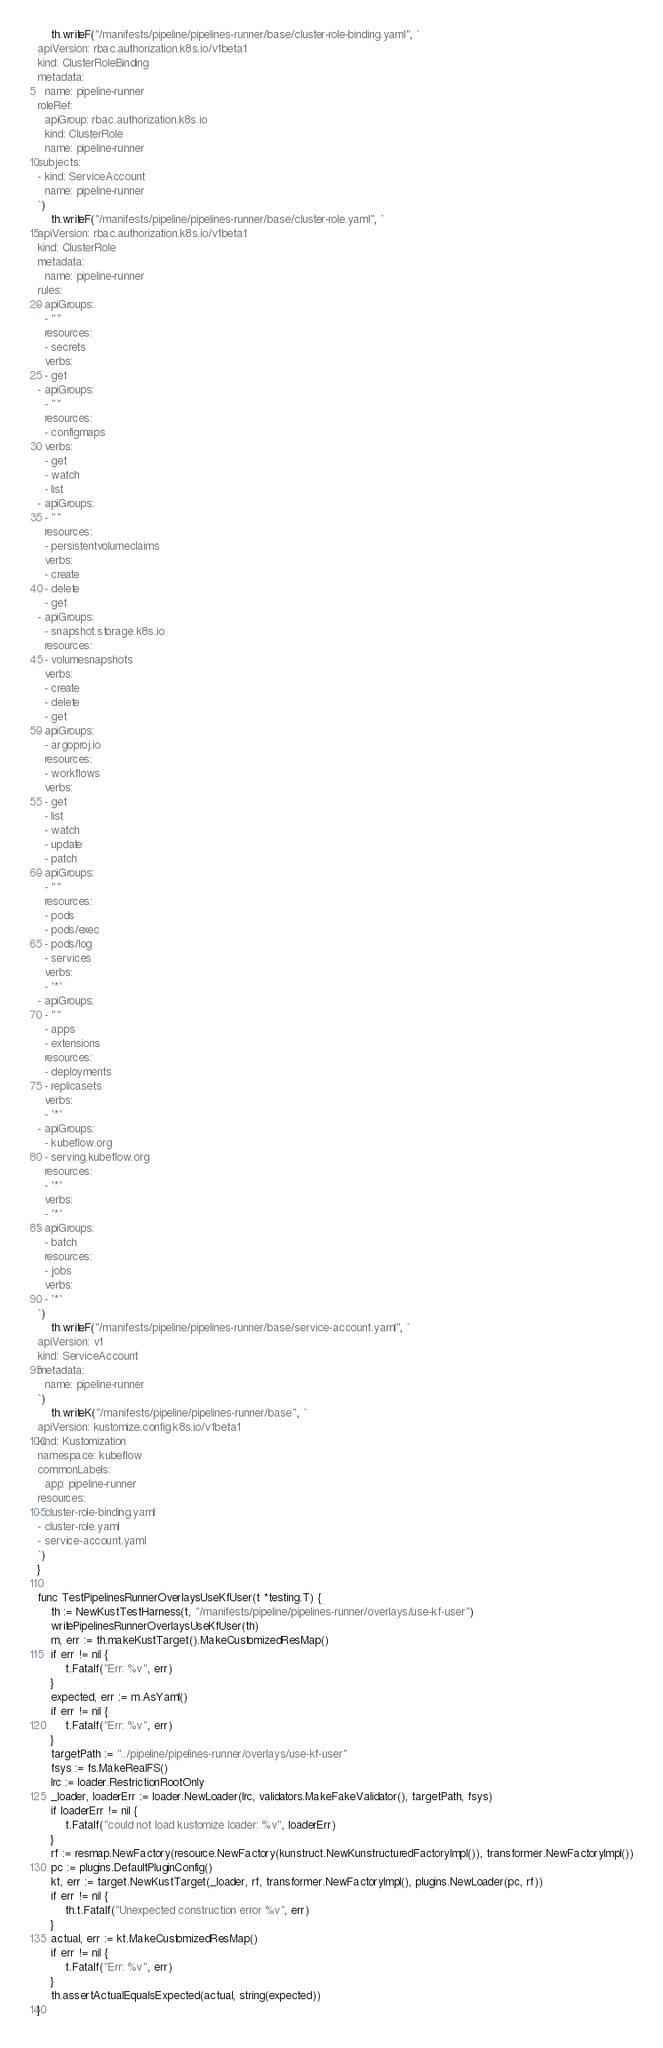<code> <loc_0><loc_0><loc_500><loc_500><_Go_>	th.writeF("/manifests/pipeline/pipelines-runner/base/cluster-role-binding.yaml", `
apiVersion: rbac.authorization.k8s.io/v1beta1
kind: ClusterRoleBinding
metadata:
  name: pipeline-runner
roleRef:
  apiGroup: rbac.authorization.k8s.io
  kind: ClusterRole
  name: pipeline-runner
subjects:
- kind: ServiceAccount
  name: pipeline-runner
`)
	th.writeF("/manifests/pipeline/pipelines-runner/base/cluster-role.yaml", `
apiVersion: rbac.authorization.k8s.io/v1beta1
kind: ClusterRole
metadata:
  name: pipeline-runner
rules:
- apiGroups:
  - ""
  resources:
  - secrets
  verbs:
  - get
- apiGroups:
  - ""
  resources:
  - configmaps
  verbs:
  - get
  - watch
  - list
- apiGroups:
  - ""
  resources:
  - persistentvolumeclaims
  verbs:
  - create
  - delete
  - get
- apiGroups:
  - snapshot.storage.k8s.io
  resources:
  - volumesnapshots
  verbs:
  - create
  - delete
  - get
- apiGroups:
  - argoproj.io
  resources:
  - workflows
  verbs:
  - get
  - list
  - watch
  - update
  - patch
- apiGroups:
  - ""
  resources:
  - pods
  - pods/exec
  - pods/log
  - services
  verbs:
  - '*'
- apiGroups:
  - ""
  - apps
  - extensions
  resources:
  - deployments
  - replicasets
  verbs:
  - '*'
- apiGroups:
  - kubeflow.org
  - serving.kubeflow.org
  resources:
  - '*'
  verbs:
  - '*'
- apiGroups:
  - batch
  resources:
  - jobs
  verbs:
  - '*'
`)
	th.writeF("/manifests/pipeline/pipelines-runner/base/service-account.yaml", `
apiVersion: v1
kind: ServiceAccount
metadata:
  name: pipeline-runner
`)
	th.writeK("/manifests/pipeline/pipelines-runner/base", `
apiVersion: kustomize.config.k8s.io/v1beta1
kind: Kustomization
namespace: kubeflow
commonLabels:
  app: pipeline-runner
resources:
- cluster-role-binding.yaml
- cluster-role.yaml
- service-account.yaml
`)
}

func TestPipelinesRunnerOverlaysUseKfUser(t *testing.T) {
	th := NewKustTestHarness(t, "/manifests/pipeline/pipelines-runner/overlays/use-kf-user")
	writePipelinesRunnerOverlaysUseKfUser(th)
	m, err := th.makeKustTarget().MakeCustomizedResMap()
	if err != nil {
		t.Fatalf("Err: %v", err)
	}
	expected, err := m.AsYaml()
	if err != nil {
		t.Fatalf("Err: %v", err)
	}
	targetPath := "../pipeline/pipelines-runner/overlays/use-kf-user"
	fsys := fs.MakeRealFS()
	lrc := loader.RestrictionRootOnly
	_loader, loaderErr := loader.NewLoader(lrc, validators.MakeFakeValidator(), targetPath, fsys)
	if loaderErr != nil {
		t.Fatalf("could not load kustomize loader: %v", loaderErr)
	}
	rf := resmap.NewFactory(resource.NewFactory(kunstruct.NewKunstructuredFactoryImpl()), transformer.NewFactoryImpl())
	pc := plugins.DefaultPluginConfig()
	kt, err := target.NewKustTarget(_loader, rf, transformer.NewFactoryImpl(), plugins.NewLoader(pc, rf))
	if err != nil {
		th.t.Fatalf("Unexpected construction error %v", err)
	}
	actual, err := kt.MakeCustomizedResMap()
	if err != nil {
		t.Fatalf("Err: %v", err)
	}
	th.assertActualEqualsExpected(actual, string(expected))
}
</code> 